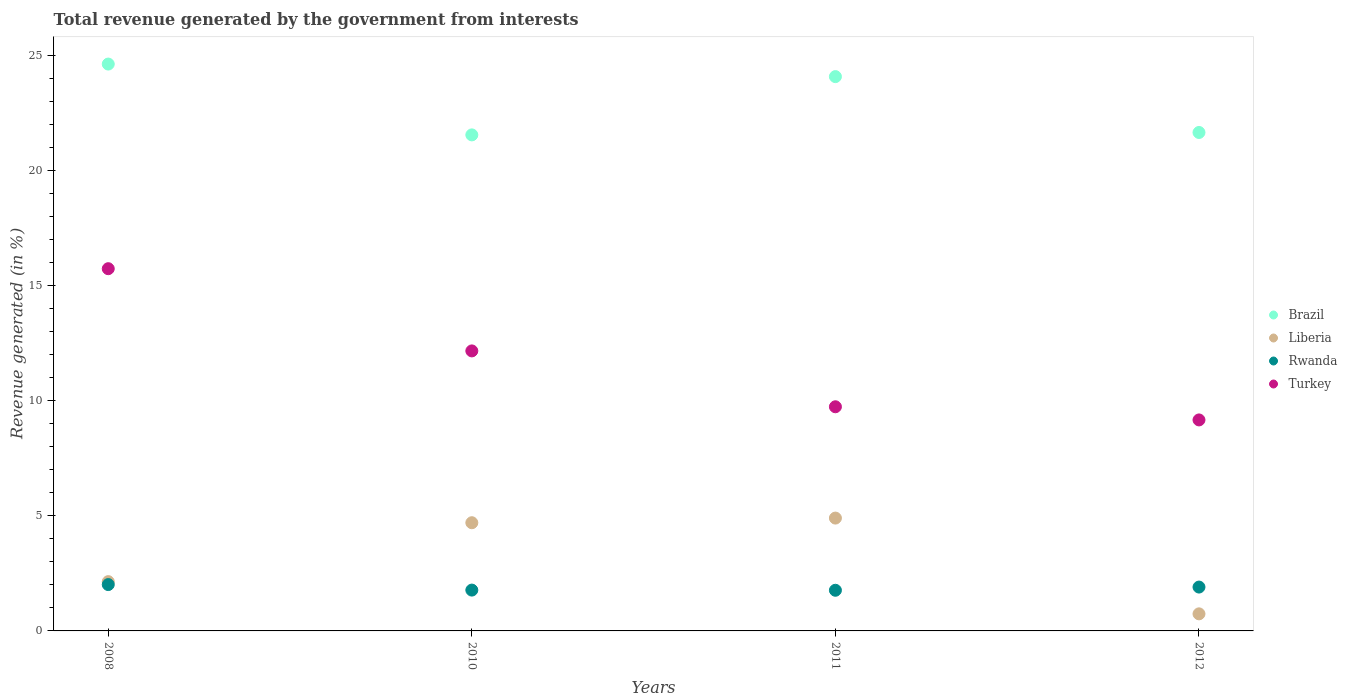How many different coloured dotlines are there?
Your answer should be very brief. 4. Is the number of dotlines equal to the number of legend labels?
Your answer should be very brief. Yes. What is the total revenue generated in Brazil in 2012?
Offer a very short reply. 21.66. Across all years, what is the maximum total revenue generated in Turkey?
Ensure brevity in your answer.  15.74. Across all years, what is the minimum total revenue generated in Turkey?
Your response must be concise. 9.17. In which year was the total revenue generated in Turkey maximum?
Offer a very short reply. 2008. In which year was the total revenue generated in Brazil minimum?
Your answer should be compact. 2010. What is the total total revenue generated in Rwanda in the graph?
Your answer should be compact. 7.46. What is the difference between the total revenue generated in Rwanda in 2010 and that in 2012?
Your answer should be compact. -0.13. What is the difference between the total revenue generated in Liberia in 2008 and the total revenue generated in Turkey in 2012?
Offer a terse response. -7.03. What is the average total revenue generated in Rwanda per year?
Make the answer very short. 1.87. In the year 2008, what is the difference between the total revenue generated in Rwanda and total revenue generated in Turkey?
Your response must be concise. -13.73. What is the ratio of the total revenue generated in Turkey in 2008 to that in 2012?
Keep it short and to the point. 1.72. Is the total revenue generated in Liberia in 2008 less than that in 2011?
Provide a short and direct response. Yes. Is the difference between the total revenue generated in Rwanda in 2008 and 2011 greater than the difference between the total revenue generated in Turkey in 2008 and 2011?
Your answer should be very brief. No. What is the difference between the highest and the second highest total revenue generated in Turkey?
Offer a very short reply. 3.57. What is the difference between the highest and the lowest total revenue generated in Brazil?
Keep it short and to the point. 3.08. Is the sum of the total revenue generated in Liberia in 2008 and 2011 greater than the maximum total revenue generated in Turkey across all years?
Provide a short and direct response. No. Does the total revenue generated in Rwanda monotonically increase over the years?
Provide a succinct answer. No. Is the total revenue generated in Brazil strictly less than the total revenue generated in Turkey over the years?
Make the answer very short. No. Are the values on the major ticks of Y-axis written in scientific E-notation?
Provide a short and direct response. No. Does the graph contain grids?
Provide a short and direct response. No. How many legend labels are there?
Make the answer very short. 4. What is the title of the graph?
Your answer should be compact. Total revenue generated by the government from interests. What is the label or title of the Y-axis?
Ensure brevity in your answer.  Revenue generated (in %). What is the Revenue generated (in %) in Brazil in 2008?
Provide a succinct answer. 24.63. What is the Revenue generated (in %) of Liberia in 2008?
Your answer should be compact. 2.14. What is the Revenue generated (in %) in Rwanda in 2008?
Your answer should be compact. 2.01. What is the Revenue generated (in %) in Turkey in 2008?
Offer a very short reply. 15.74. What is the Revenue generated (in %) of Brazil in 2010?
Keep it short and to the point. 21.56. What is the Revenue generated (in %) in Liberia in 2010?
Offer a terse response. 4.7. What is the Revenue generated (in %) in Rwanda in 2010?
Make the answer very short. 1.77. What is the Revenue generated (in %) of Turkey in 2010?
Make the answer very short. 12.17. What is the Revenue generated (in %) in Brazil in 2011?
Offer a very short reply. 24.09. What is the Revenue generated (in %) in Liberia in 2011?
Ensure brevity in your answer.  4.9. What is the Revenue generated (in %) in Rwanda in 2011?
Your answer should be compact. 1.77. What is the Revenue generated (in %) of Turkey in 2011?
Keep it short and to the point. 9.74. What is the Revenue generated (in %) in Brazil in 2012?
Your answer should be compact. 21.66. What is the Revenue generated (in %) of Liberia in 2012?
Ensure brevity in your answer.  0.74. What is the Revenue generated (in %) in Rwanda in 2012?
Offer a terse response. 1.91. What is the Revenue generated (in %) in Turkey in 2012?
Provide a succinct answer. 9.17. Across all years, what is the maximum Revenue generated (in %) of Brazil?
Offer a very short reply. 24.63. Across all years, what is the maximum Revenue generated (in %) of Liberia?
Offer a very short reply. 4.9. Across all years, what is the maximum Revenue generated (in %) of Rwanda?
Provide a succinct answer. 2.01. Across all years, what is the maximum Revenue generated (in %) in Turkey?
Provide a succinct answer. 15.74. Across all years, what is the minimum Revenue generated (in %) in Brazil?
Provide a short and direct response. 21.56. Across all years, what is the minimum Revenue generated (in %) in Liberia?
Make the answer very short. 0.74. Across all years, what is the minimum Revenue generated (in %) in Rwanda?
Provide a succinct answer. 1.77. Across all years, what is the minimum Revenue generated (in %) of Turkey?
Your answer should be very brief. 9.17. What is the total Revenue generated (in %) of Brazil in the graph?
Keep it short and to the point. 91.94. What is the total Revenue generated (in %) in Liberia in the graph?
Offer a very short reply. 12.49. What is the total Revenue generated (in %) in Rwanda in the graph?
Keep it short and to the point. 7.46. What is the total Revenue generated (in %) of Turkey in the graph?
Provide a short and direct response. 46.82. What is the difference between the Revenue generated (in %) in Brazil in 2008 and that in 2010?
Provide a succinct answer. 3.08. What is the difference between the Revenue generated (in %) in Liberia in 2008 and that in 2010?
Ensure brevity in your answer.  -2.56. What is the difference between the Revenue generated (in %) of Rwanda in 2008 and that in 2010?
Your answer should be compact. 0.24. What is the difference between the Revenue generated (in %) of Turkey in 2008 and that in 2010?
Offer a terse response. 3.57. What is the difference between the Revenue generated (in %) in Brazil in 2008 and that in 2011?
Ensure brevity in your answer.  0.55. What is the difference between the Revenue generated (in %) of Liberia in 2008 and that in 2011?
Your answer should be very brief. -2.76. What is the difference between the Revenue generated (in %) in Rwanda in 2008 and that in 2011?
Ensure brevity in your answer.  0.25. What is the difference between the Revenue generated (in %) in Turkey in 2008 and that in 2011?
Your response must be concise. 6. What is the difference between the Revenue generated (in %) of Brazil in 2008 and that in 2012?
Your response must be concise. 2.97. What is the difference between the Revenue generated (in %) in Liberia in 2008 and that in 2012?
Keep it short and to the point. 1.4. What is the difference between the Revenue generated (in %) in Rwanda in 2008 and that in 2012?
Offer a terse response. 0.11. What is the difference between the Revenue generated (in %) of Turkey in 2008 and that in 2012?
Make the answer very short. 6.57. What is the difference between the Revenue generated (in %) of Brazil in 2010 and that in 2011?
Give a very brief answer. -2.53. What is the difference between the Revenue generated (in %) of Liberia in 2010 and that in 2011?
Give a very brief answer. -0.2. What is the difference between the Revenue generated (in %) in Rwanda in 2010 and that in 2011?
Provide a succinct answer. 0.01. What is the difference between the Revenue generated (in %) in Turkey in 2010 and that in 2011?
Give a very brief answer. 2.43. What is the difference between the Revenue generated (in %) in Brazil in 2010 and that in 2012?
Give a very brief answer. -0.1. What is the difference between the Revenue generated (in %) in Liberia in 2010 and that in 2012?
Give a very brief answer. 3.96. What is the difference between the Revenue generated (in %) of Rwanda in 2010 and that in 2012?
Keep it short and to the point. -0.13. What is the difference between the Revenue generated (in %) in Turkey in 2010 and that in 2012?
Ensure brevity in your answer.  3. What is the difference between the Revenue generated (in %) of Brazil in 2011 and that in 2012?
Offer a very short reply. 2.43. What is the difference between the Revenue generated (in %) of Liberia in 2011 and that in 2012?
Provide a succinct answer. 4.16. What is the difference between the Revenue generated (in %) of Rwanda in 2011 and that in 2012?
Offer a terse response. -0.14. What is the difference between the Revenue generated (in %) in Turkey in 2011 and that in 2012?
Ensure brevity in your answer.  0.57. What is the difference between the Revenue generated (in %) in Brazil in 2008 and the Revenue generated (in %) in Liberia in 2010?
Provide a succinct answer. 19.93. What is the difference between the Revenue generated (in %) in Brazil in 2008 and the Revenue generated (in %) in Rwanda in 2010?
Provide a succinct answer. 22.86. What is the difference between the Revenue generated (in %) of Brazil in 2008 and the Revenue generated (in %) of Turkey in 2010?
Your answer should be very brief. 12.47. What is the difference between the Revenue generated (in %) of Liberia in 2008 and the Revenue generated (in %) of Rwanda in 2010?
Make the answer very short. 0.37. What is the difference between the Revenue generated (in %) in Liberia in 2008 and the Revenue generated (in %) in Turkey in 2010?
Your answer should be very brief. -10.03. What is the difference between the Revenue generated (in %) of Rwanda in 2008 and the Revenue generated (in %) of Turkey in 2010?
Offer a terse response. -10.15. What is the difference between the Revenue generated (in %) of Brazil in 2008 and the Revenue generated (in %) of Liberia in 2011?
Offer a terse response. 19.73. What is the difference between the Revenue generated (in %) of Brazil in 2008 and the Revenue generated (in %) of Rwanda in 2011?
Offer a very short reply. 22.87. What is the difference between the Revenue generated (in %) of Brazil in 2008 and the Revenue generated (in %) of Turkey in 2011?
Your response must be concise. 14.89. What is the difference between the Revenue generated (in %) in Liberia in 2008 and the Revenue generated (in %) in Rwanda in 2011?
Make the answer very short. 0.37. What is the difference between the Revenue generated (in %) of Liberia in 2008 and the Revenue generated (in %) of Turkey in 2011?
Your answer should be compact. -7.6. What is the difference between the Revenue generated (in %) of Rwanda in 2008 and the Revenue generated (in %) of Turkey in 2011?
Your answer should be compact. -7.73. What is the difference between the Revenue generated (in %) in Brazil in 2008 and the Revenue generated (in %) in Liberia in 2012?
Keep it short and to the point. 23.89. What is the difference between the Revenue generated (in %) in Brazil in 2008 and the Revenue generated (in %) in Rwanda in 2012?
Make the answer very short. 22.73. What is the difference between the Revenue generated (in %) of Brazil in 2008 and the Revenue generated (in %) of Turkey in 2012?
Your answer should be very brief. 15.46. What is the difference between the Revenue generated (in %) of Liberia in 2008 and the Revenue generated (in %) of Rwanda in 2012?
Provide a short and direct response. 0.24. What is the difference between the Revenue generated (in %) in Liberia in 2008 and the Revenue generated (in %) in Turkey in 2012?
Provide a succinct answer. -7.03. What is the difference between the Revenue generated (in %) of Rwanda in 2008 and the Revenue generated (in %) of Turkey in 2012?
Offer a terse response. -7.16. What is the difference between the Revenue generated (in %) of Brazil in 2010 and the Revenue generated (in %) of Liberia in 2011?
Give a very brief answer. 16.65. What is the difference between the Revenue generated (in %) of Brazil in 2010 and the Revenue generated (in %) of Rwanda in 2011?
Your response must be concise. 19.79. What is the difference between the Revenue generated (in %) of Brazil in 2010 and the Revenue generated (in %) of Turkey in 2011?
Ensure brevity in your answer.  11.81. What is the difference between the Revenue generated (in %) in Liberia in 2010 and the Revenue generated (in %) in Rwanda in 2011?
Provide a short and direct response. 2.93. What is the difference between the Revenue generated (in %) of Liberia in 2010 and the Revenue generated (in %) of Turkey in 2011?
Provide a short and direct response. -5.04. What is the difference between the Revenue generated (in %) of Rwanda in 2010 and the Revenue generated (in %) of Turkey in 2011?
Provide a short and direct response. -7.97. What is the difference between the Revenue generated (in %) in Brazil in 2010 and the Revenue generated (in %) in Liberia in 2012?
Give a very brief answer. 20.81. What is the difference between the Revenue generated (in %) of Brazil in 2010 and the Revenue generated (in %) of Rwanda in 2012?
Offer a terse response. 19.65. What is the difference between the Revenue generated (in %) in Brazil in 2010 and the Revenue generated (in %) in Turkey in 2012?
Offer a terse response. 12.39. What is the difference between the Revenue generated (in %) in Liberia in 2010 and the Revenue generated (in %) in Rwanda in 2012?
Ensure brevity in your answer.  2.8. What is the difference between the Revenue generated (in %) of Liberia in 2010 and the Revenue generated (in %) of Turkey in 2012?
Offer a terse response. -4.47. What is the difference between the Revenue generated (in %) in Rwanda in 2010 and the Revenue generated (in %) in Turkey in 2012?
Provide a succinct answer. -7.39. What is the difference between the Revenue generated (in %) of Brazil in 2011 and the Revenue generated (in %) of Liberia in 2012?
Give a very brief answer. 23.35. What is the difference between the Revenue generated (in %) of Brazil in 2011 and the Revenue generated (in %) of Rwanda in 2012?
Keep it short and to the point. 22.18. What is the difference between the Revenue generated (in %) of Brazil in 2011 and the Revenue generated (in %) of Turkey in 2012?
Give a very brief answer. 14.92. What is the difference between the Revenue generated (in %) in Liberia in 2011 and the Revenue generated (in %) in Rwanda in 2012?
Your answer should be compact. 3. What is the difference between the Revenue generated (in %) of Liberia in 2011 and the Revenue generated (in %) of Turkey in 2012?
Your response must be concise. -4.27. What is the difference between the Revenue generated (in %) in Rwanda in 2011 and the Revenue generated (in %) in Turkey in 2012?
Offer a terse response. -7.4. What is the average Revenue generated (in %) in Brazil per year?
Ensure brevity in your answer.  22.98. What is the average Revenue generated (in %) of Liberia per year?
Your answer should be very brief. 3.12. What is the average Revenue generated (in %) in Rwanda per year?
Offer a terse response. 1.87. What is the average Revenue generated (in %) in Turkey per year?
Offer a very short reply. 11.7. In the year 2008, what is the difference between the Revenue generated (in %) of Brazil and Revenue generated (in %) of Liberia?
Your answer should be very brief. 22.49. In the year 2008, what is the difference between the Revenue generated (in %) in Brazil and Revenue generated (in %) in Rwanda?
Keep it short and to the point. 22.62. In the year 2008, what is the difference between the Revenue generated (in %) in Brazil and Revenue generated (in %) in Turkey?
Your answer should be very brief. 8.89. In the year 2008, what is the difference between the Revenue generated (in %) in Liberia and Revenue generated (in %) in Rwanda?
Offer a terse response. 0.13. In the year 2008, what is the difference between the Revenue generated (in %) in Liberia and Revenue generated (in %) in Turkey?
Offer a terse response. -13.6. In the year 2008, what is the difference between the Revenue generated (in %) of Rwanda and Revenue generated (in %) of Turkey?
Offer a terse response. -13.73. In the year 2010, what is the difference between the Revenue generated (in %) of Brazil and Revenue generated (in %) of Liberia?
Offer a terse response. 16.85. In the year 2010, what is the difference between the Revenue generated (in %) in Brazil and Revenue generated (in %) in Rwanda?
Offer a very short reply. 19.78. In the year 2010, what is the difference between the Revenue generated (in %) of Brazil and Revenue generated (in %) of Turkey?
Ensure brevity in your answer.  9.39. In the year 2010, what is the difference between the Revenue generated (in %) of Liberia and Revenue generated (in %) of Rwanda?
Give a very brief answer. 2.93. In the year 2010, what is the difference between the Revenue generated (in %) of Liberia and Revenue generated (in %) of Turkey?
Ensure brevity in your answer.  -7.47. In the year 2010, what is the difference between the Revenue generated (in %) in Rwanda and Revenue generated (in %) in Turkey?
Provide a succinct answer. -10.39. In the year 2011, what is the difference between the Revenue generated (in %) in Brazil and Revenue generated (in %) in Liberia?
Provide a short and direct response. 19.18. In the year 2011, what is the difference between the Revenue generated (in %) in Brazil and Revenue generated (in %) in Rwanda?
Provide a short and direct response. 22.32. In the year 2011, what is the difference between the Revenue generated (in %) of Brazil and Revenue generated (in %) of Turkey?
Your response must be concise. 14.35. In the year 2011, what is the difference between the Revenue generated (in %) of Liberia and Revenue generated (in %) of Rwanda?
Your answer should be compact. 3.14. In the year 2011, what is the difference between the Revenue generated (in %) of Liberia and Revenue generated (in %) of Turkey?
Provide a short and direct response. -4.84. In the year 2011, what is the difference between the Revenue generated (in %) of Rwanda and Revenue generated (in %) of Turkey?
Your answer should be very brief. -7.97. In the year 2012, what is the difference between the Revenue generated (in %) of Brazil and Revenue generated (in %) of Liberia?
Offer a very short reply. 20.92. In the year 2012, what is the difference between the Revenue generated (in %) of Brazil and Revenue generated (in %) of Rwanda?
Your response must be concise. 19.75. In the year 2012, what is the difference between the Revenue generated (in %) of Brazil and Revenue generated (in %) of Turkey?
Make the answer very short. 12.49. In the year 2012, what is the difference between the Revenue generated (in %) of Liberia and Revenue generated (in %) of Rwanda?
Offer a very short reply. -1.16. In the year 2012, what is the difference between the Revenue generated (in %) of Liberia and Revenue generated (in %) of Turkey?
Your response must be concise. -8.43. In the year 2012, what is the difference between the Revenue generated (in %) of Rwanda and Revenue generated (in %) of Turkey?
Offer a very short reply. -7.26. What is the ratio of the Revenue generated (in %) of Brazil in 2008 to that in 2010?
Give a very brief answer. 1.14. What is the ratio of the Revenue generated (in %) in Liberia in 2008 to that in 2010?
Your answer should be very brief. 0.46. What is the ratio of the Revenue generated (in %) of Rwanda in 2008 to that in 2010?
Your answer should be compact. 1.14. What is the ratio of the Revenue generated (in %) of Turkey in 2008 to that in 2010?
Your answer should be compact. 1.29. What is the ratio of the Revenue generated (in %) of Brazil in 2008 to that in 2011?
Keep it short and to the point. 1.02. What is the ratio of the Revenue generated (in %) of Liberia in 2008 to that in 2011?
Give a very brief answer. 0.44. What is the ratio of the Revenue generated (in %) of Rwanda in 2008 to that in 2011?
Provide a succinct answer. 1.14. What is the ratio of the Revenue generated (in %) in Turkey in 2008 to that in 2011?
Provide a short and direct response. 1.62. What is the ratio of the Revenue generated (in %) in Brazil in 2008 to that in 2012?
Provide a succinct answer. 1.14. What is the ratio of the Revenue generated (in %) of Liberia in 2008 to that in 2012?
Offer a terse response. 2.89. What is the ratio of the Revenue generated (in %) of Rwanda in 2008 to that in 2012?
Make the answer very short. 1.06. What is the ratio of the Revenue generated (in %) in Turkey in 2008 to that in 2012?
Offer a very short reply. 1.72. What is the ratio of the Revenue generated (in %) of Brazil in 2010 to that in 2011?
Provide a short and direct response. 0.89. What is the ratio of the Revenue generated (in %) of Liberia in 2010 to that in 2011?
Ensure brevity in your answer.  0.96. What is the ratio of the Revenue generated (in %) of Rwanda in 2010 to that in 2011?
Give a very brief answer. 1. What is the ratio of the Revenue generated (in %) in Turkey in 2010 to that in 2011?
Make the answer very short. 1.25. What is the ratio of the Revenue generated (in %) of Brazil in 2010 to that in 2012?
Offer a terse response. 1. What is the ratio of the Revenue generated (in %) of Liberia in 2010 to that in 2012?
Make the answer very short. 6.34. What is the ratio of the Revenue generated (in %) in Rwanda in 2010 to that in 2012?
Offer a terse response. 0.93. What is the ratio of the Revenue generated (in %) of Turkey in 2010 to that in 2012?
Your response must be concise. 1.33. What is the ratio of the Revenue generated (in %) in Brazil in 2011 to that in 2012?
Your response must be concise. 1.11. What is the ratio of the Revenue generated (in %) in Liberia in 2011 to that in 2012?
Your answer should be very brief. 6.61. What is the ratio of the Revenue generated (in %) in Rwanda in 2011 to that in 2012?
Offer a very short reply. 0.93. What is the ratio of the Revenue generated (in %) in Turkey in 2011 to that in 2012?
Give a very brief answer. 1.06. What is the difference between the highest and the second highest Revenue generated (in %) in Brazil?
Make the answer very short. 0.55. What is the difference between the highest and the second highest Revenue generated (in %) of Liberia?
Make the answer very short. 0.2. What is the difference between the highest and the second highest Revenue generated (in %) in Rwanda?
Your response must be concise. 0.11. What is the difference between the highest and the second highest Revenue generated (in %) in Turkey?
Your answer should be very brief. 3.57. What is the difference between the highest and the lowest Revenue generated (in %) of Brazil?
Offer a terse response. 3.08. What is the difference between the highest and the lowest Revenue generated (in %) in Liberia?
Make the answer very short. 4.16. What is the difference between the highest and the lowest Revenue generated (in %) of Rwanda?
Keep it short and to the point. 0.25. What is the difference between the highest and the lowest Revenue generated (in %) in Turkey?
Make the answer very short. 6.57. 